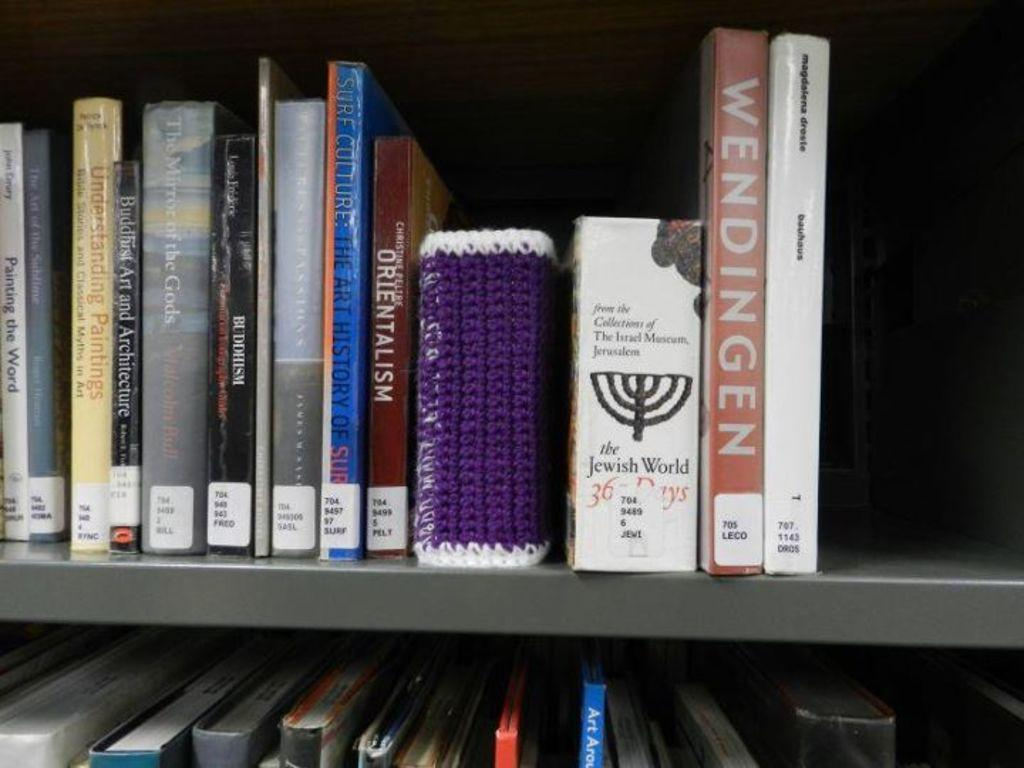What objects are present in the image? There are books in the image. Where are the books located? The books are in the racks. What can be observed about the appearance of the books? The books are in multiple colors. Can you describe the motion of the stone during the rainstorm in the image? There is no stone or rainstorm present in the image; it features books in racks. 